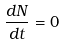Convert formula to latex. <formula><loc_0><loc_0><loc_500><loc_500>\frac { d N } { d t } = 0</formula> 